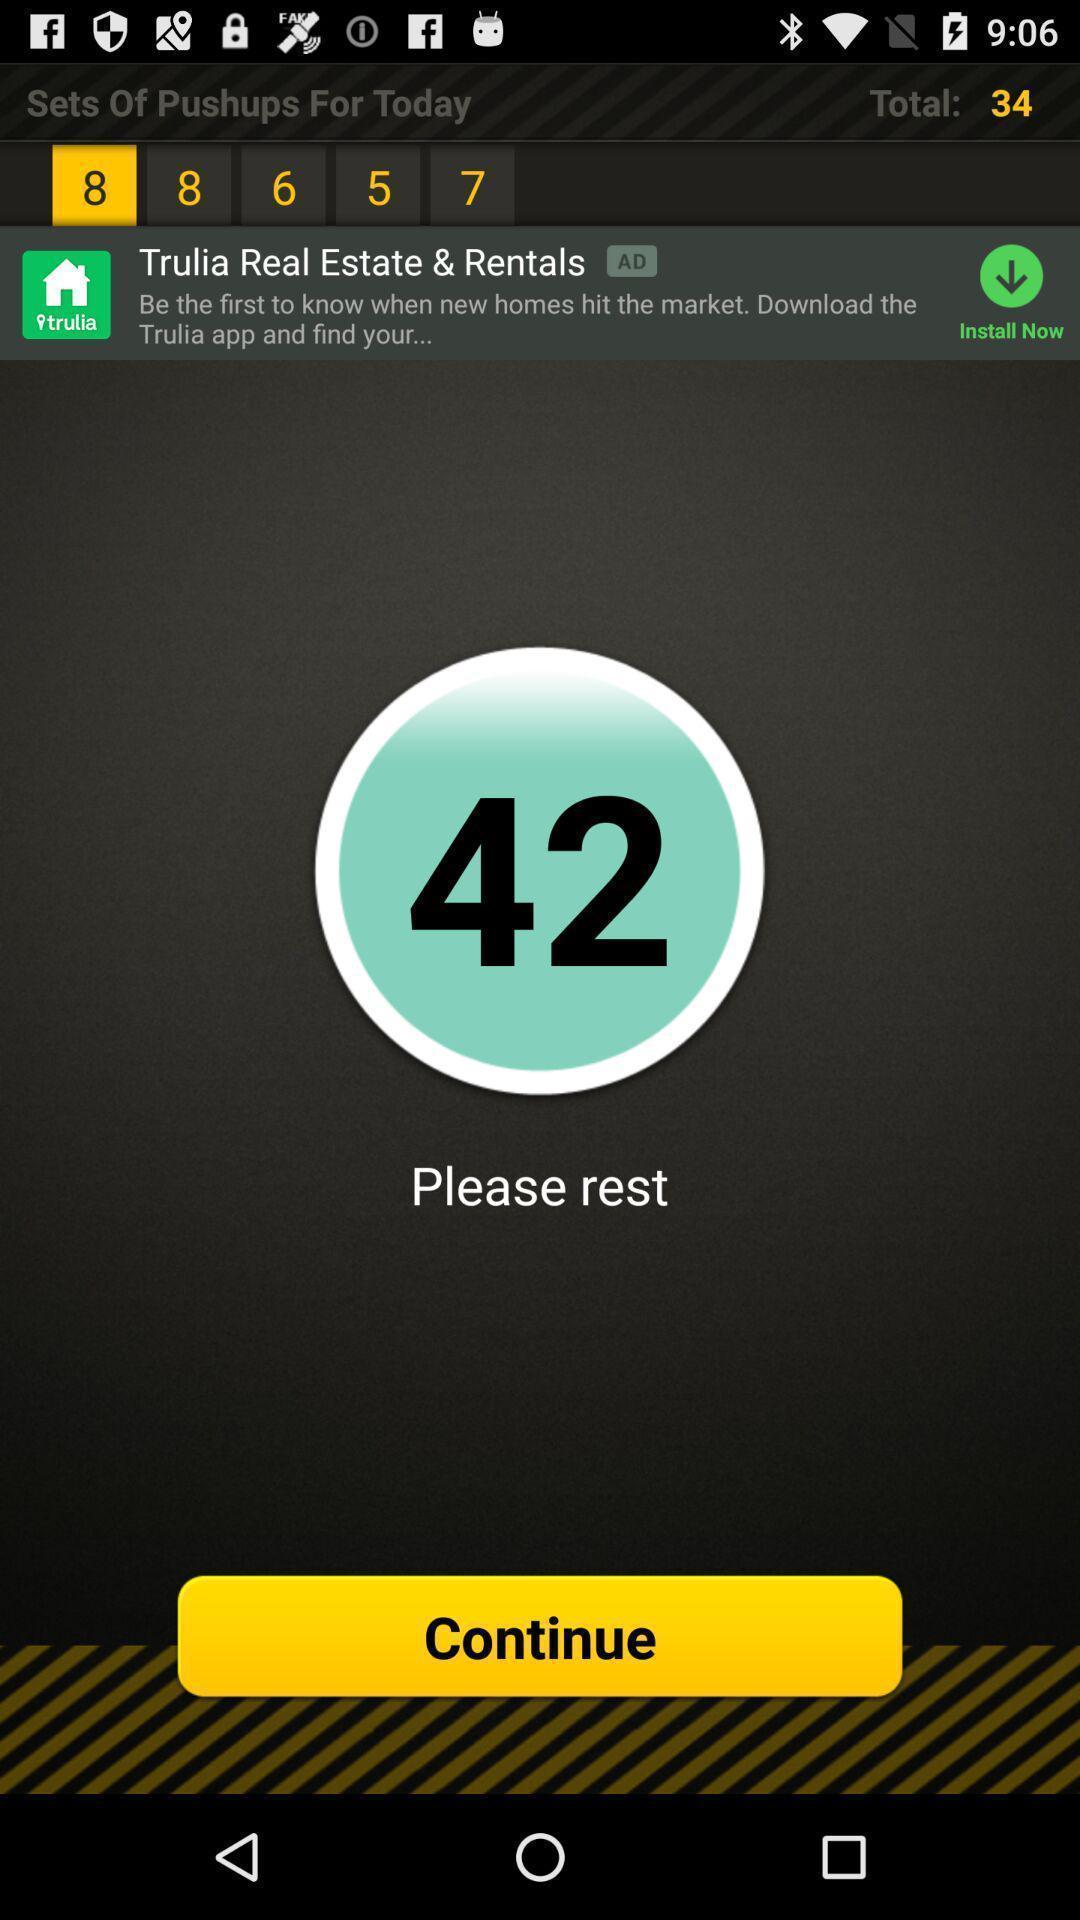Provide a description of this screenshot. Page to continue in the fitness app. 